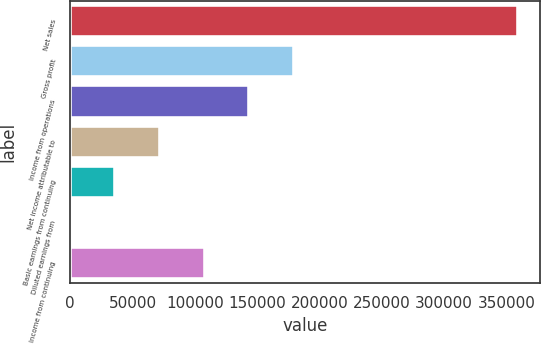Convert chart to OTSL. <chart><loc_0><loc_0><loc_500><loc_500><bar_chart><fcel>Net sales<fcel>Gross profit<fcel>Income from operations<fcel>Net income attributable to<fcel>Basic earnings from continuing<fcel>Diluted earnings from<fcel>Income from continuing<nl><fcel>359188<fcel>179594<fcel>143676<fcel>71838<fcel>35919.2<fcel>0.5<fcel>107757<nl></chart> 